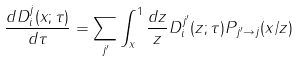Convert formula to latex. <formula><loc_0><loc_0><loc_500><loc_500>\frac { d D _ { i } ^ { j } ( x ; \tau ) } { d \tau } = \sum _ { j ^ { \prime } } \int _ { x } ^ { 1 } \frac { d z } { z } D _ { i } ^ { j ^ { \prime } } ( z ; \tau ) P _ { j ^ { \prime } \to j } ( x / z )</formula> 